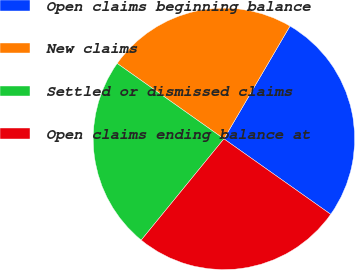Convert chart. <chart><loc_0><loc_0><loc_500><loc_500><pie_chart><fcel>Open claims beginning balance<fcel>New claims<fcel>Settled or dismissed claims<fcel>Open claims ending balance at<nl><fcel>26.36%<fcel>23.64%<fcel>23.89%<fcel>26.11%<nl></chart> 